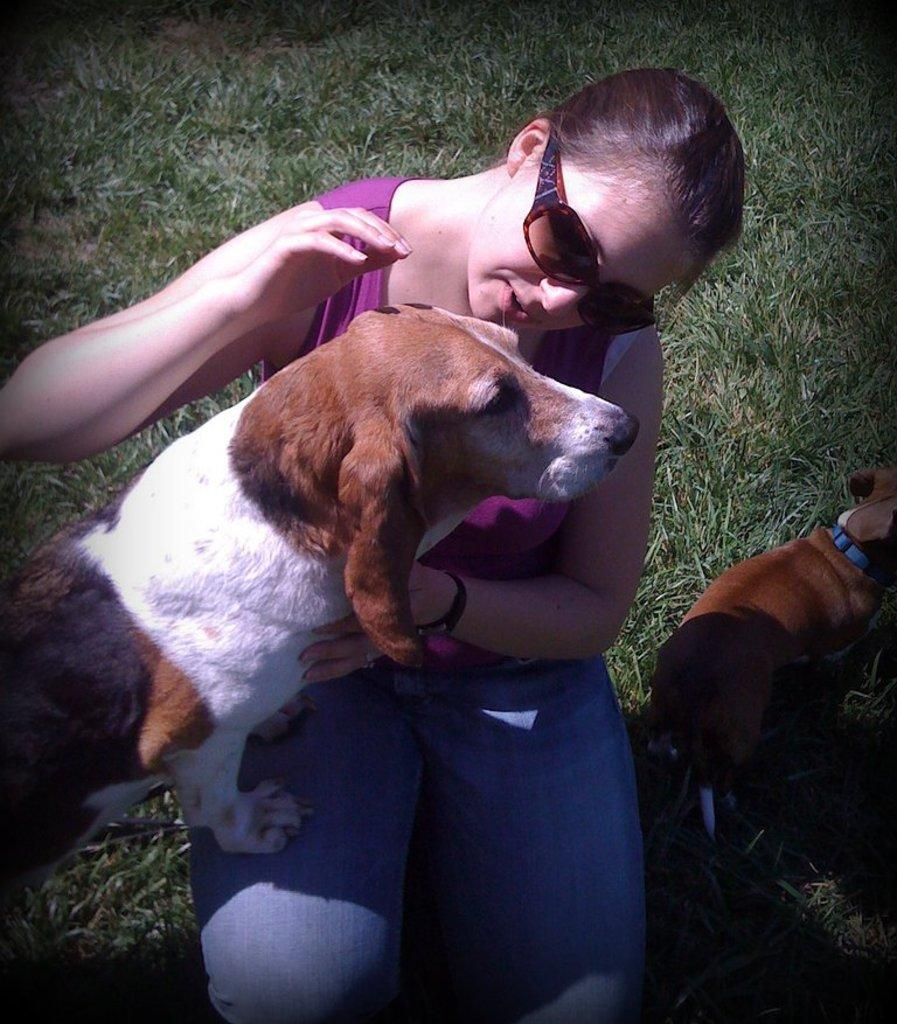Who is present in the image? There is a lady in the image. What is the lady doing in the image? The lady is sitting on the grass. What is the lady holding in the image? The lady is holding grass. Is there any other living creature in the image? Yes, there is a puppy in the image. How is the puppy positioned in relation to the lady? The puppy is standing beside the lady. What month is it in the image? The month is not mentioned or depicted in the image, so it cannot be determined. 